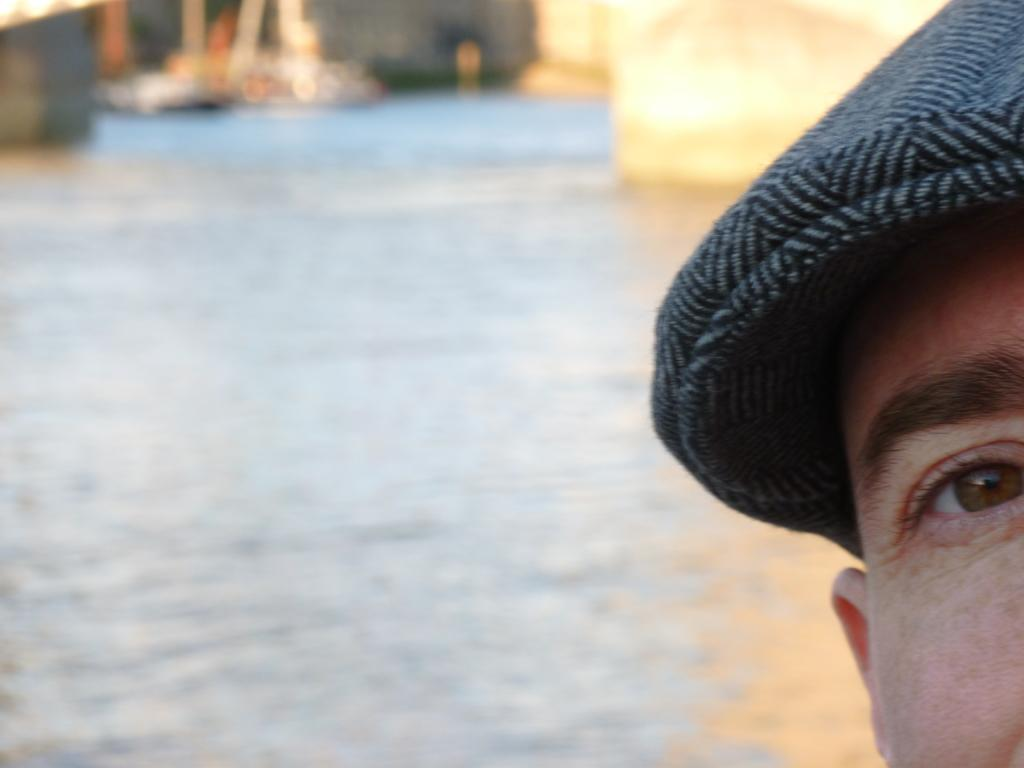What is the primary element in the picture? There is water in the picture. Is there anyone present in the image? Yes, there is a person in the picture. What is the person wearing on their head? The person is wearing a cap. What type of paste is the person using to write in the notebook in the image? There is no notebook or paste present in the image; it only features water and a person wearing a cap. 